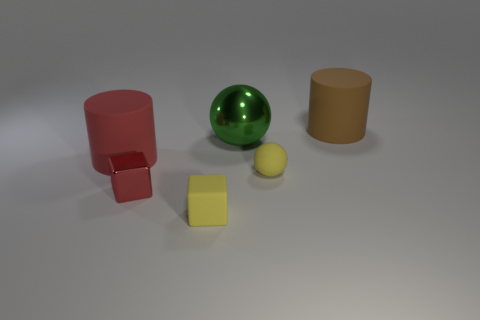How many things are either spheres in front of the large metal object or tiny objects behind the small red metal cube?
Offer a terse response. 1. What size is the yellow matte block that is right of the red cube in front of the cylinder that is in front of the brown thing?
Provide a succinct answer. Small. Is the number of large red rubber objects that are in front of the tiny yellow rubber block the same as the number of big green spheres?
Ensure brevity in your answer.  No. Is there any other thing that has the same shape as the large red object?
Your response must be concise. Yes. There is a large brown matte object; is it the same shape as the big matte thing to the left of the large green object?
Give a very brief answer. Yes. What size is the rubber object that is the same shape as the big shiny thing?
Your answer should be compact. Small. How many other things are there of the same material as the tiny yellow cube?
Keep it short and to the point. 3. What is the big brown cylinder made of?
Ensure brevity in your answer.  Rubber. Is the color of the matte cylinder in front of the brown matte cylinder the same as the rubber cube that is to the right of the small red metallic thing?
Your response must be concise. No. Is the number of yellow blocks left of the brown thing greater than the number of yellow rubber things?
Your response must be concise. No. 